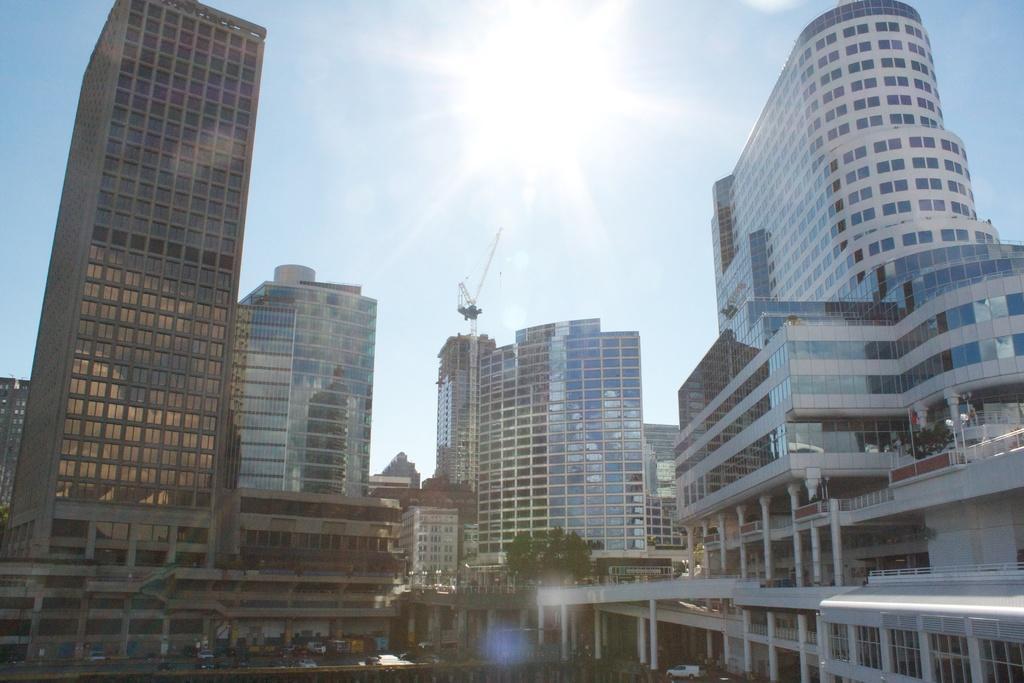In one or two sentences, can you explain what this image depicts? In this picture we can see buildings, vehicles on the road, trees and in the background we can see the sky. 